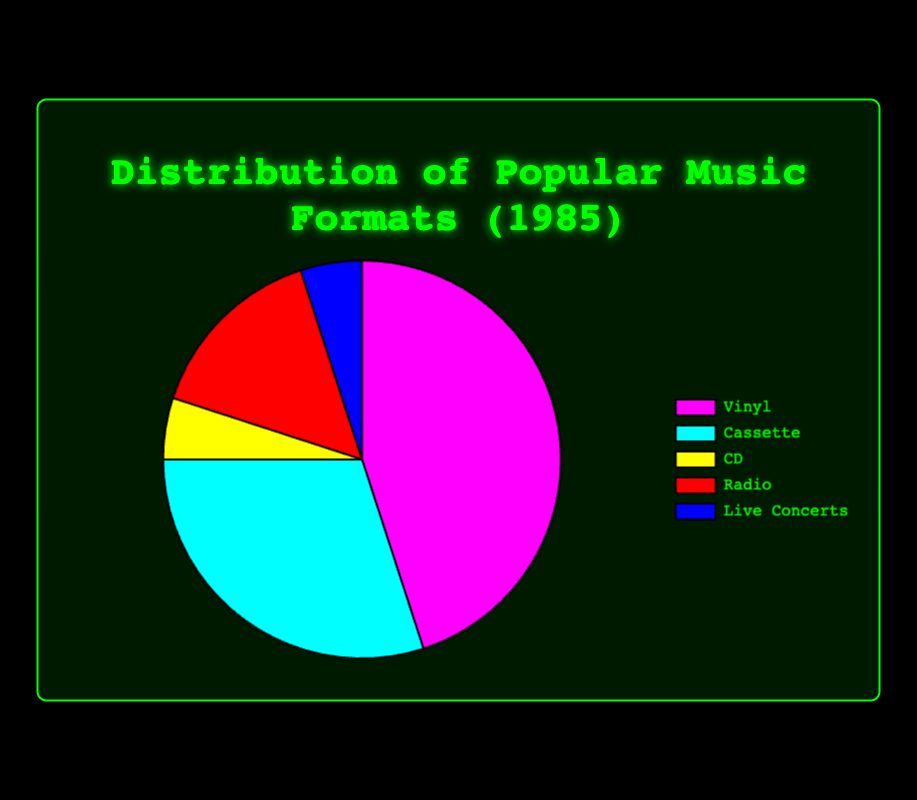What percentage of music formats in 1985 were either Vinyl or Cassettes combined? To find the combined percentage of Vinyl and Cassettes, add their individual percentages. Vinyl has 45% and Cassettes have 30%. Therefore, 45% + 30% = 75%.
Answer: 75% Which music format was more popular in 1985, Radio or CDs? To determine the more popular format between Radio and CDs, we compare their percentages. Radio has 15% and CDs have 5%. Since 15% is greater than 5%, Radio was more popular.
Answer: Radio Among the displayed formats, which two have the least percentage and what is their combined percentage? To find the two formats with the least percentage, we look at their individual percentages. CDs and Live Concerts both have 5%. Adding them gives 5% + 5% = 10%.
Answer: CDs and Live Concerts, 10% If Vinyl's percentage decreased by 10% and this amount was equally distributed to CDs and Live Concerts, what would their new percentages be? Vinyl's decrease of 10% would add 5% to CDs and 5% to Live Concerts since it is equally divided. Therefore, CDs' new percentage is 5% + 5% = 10% and Live Concerts' new percentage is 5% + 5% = 10%.
Answer: CDs: 10%, Live Concerts: 10% Which color represents the Vinyl format in the pie chart? The color representing Vinyl in the pie chart is observed from the visual chart. Vinyl is represented by the color magenta.
Answer: Magenta Rank all the music formats in 1985 from the most to least popular based on their percentages. By comparing their percentages, we can rank the formats:
1. Vinyl (45%)
2. Cassette (30%)
3. Radio (15%)
4. CD (5%)
5. Live Concerts (5%)
Answer: Vinyl, Cassette, Radio, CD, Live Concerts How much more popular was listening to music on the radio compared to attending live concerts in 1985? To find the difference in popularity, subtract the percentage of Live Concerts from the percentage of Radio. Radio is 15% and Live Concerts is 5%, so 15% - 5% = 10%.
Answer: 10% What percentage of the music formats in 1985 did neither CDs nor Live Concerts account for? To find the percentage not accounted for by CDs and Live Concerts, subtract their combined percentage from 100%. CDs and Live Concerts together are 5% + 5% = 10%. Therefore, 100% - 10% = 90%.
Answer: 90% 